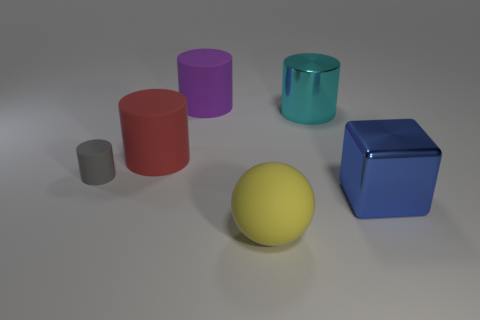Can you describe the textures and materials of the objects depicted in the image? Certainly! In the image, the objects display a variety of textures. The cylinders and cubes have smooth, matte surfaces, suggesting they could be made of plastic or painted with a non-glossy finish. The sphere in the center has a slightly reflective surface, which could imply a polished metal or plastic material. 